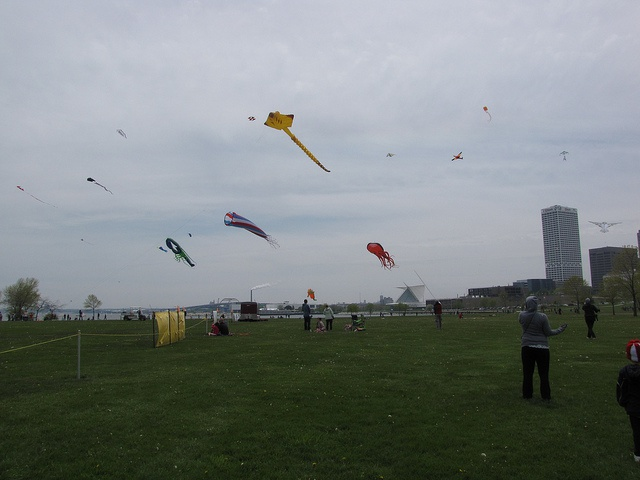Describe the objects in this image and their specific colors. I can see people in darkgray, black, gray, and darkgreen tones, people in darkgray, black, gray, and darkgreen tones, people in darkgray, black, gray, and maroon tones, kite in darkgray, olive, and maroon tones, and kite in darkgray, gray, maroon, and navy tones in this image. 